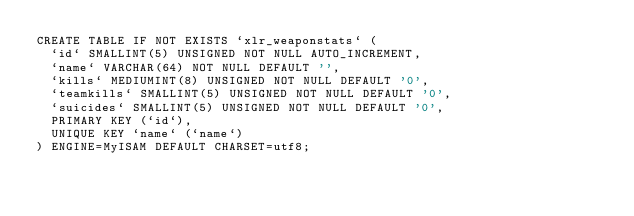<code> <loc_0><loc_0><loc_500><loc_500><_SQL_>CREATE TABLE IF NOT EXISTS `xlr_weaponstats` (
  `id` SMALLINT(5) UNSIGNED NOT NULL AUTO_INCREMENT,
  `name` VARCHAR(64) NOT NULL DEFAULT '',
  `kills` MEDIUMINT(8) UNSIGNED NOT NULL DEFAULT '0',
  `teamkills` SMALLINT(5) UNSIGNED NOT NULL DEFAULT '0',
  `suicides` SMALLINT(5) UNSIGNED NOT NULL DEFAULT '0',
  PRIMARY KEY (`id`),
  UNIQUE KEY `name` (`name`)
) ENGINE=MyISAM DEFAULT CHARSET=utf8;</code> 